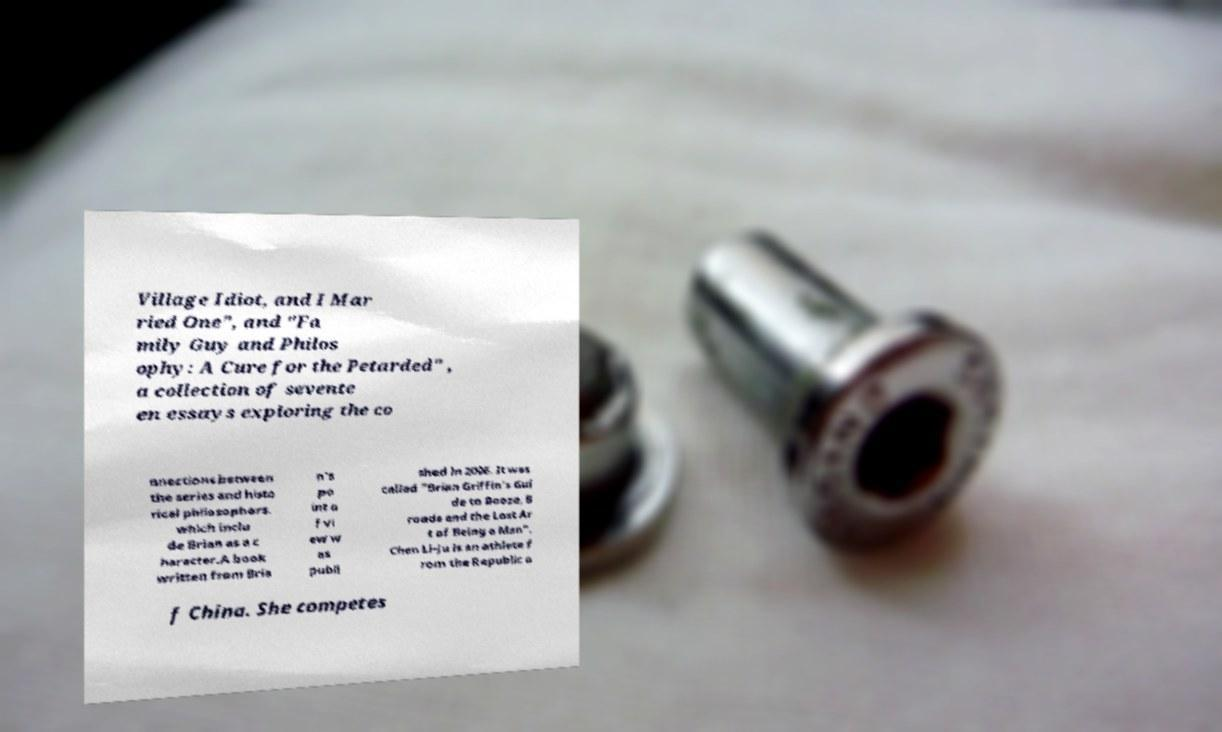Please read and relay the text visible in this image. What does it say? Village Idiot, and I Mar ried One", and "Fa mily Guy and Philos ophy: A Cure for the Petarded" , a collection of sevente en essays exploring the co nnections between the series and histo rical philosophers. which inclu de Brian as a c haracter.A book written from Bria n's po int o f vi ew w as publi shed in 2006. It was called "Brian Griffin's Gui de to Booze, B roads and the Lost Ar t of Being a Man". Chen Li-Ju is an athlete f rom the Republic o f China. She competes 